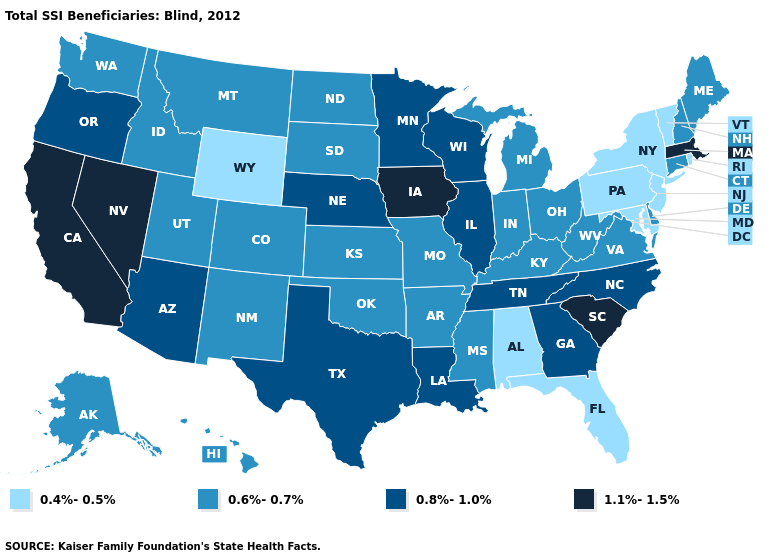Name the states that have a value in the range 0.6%-0.7%?
Write a very short answer. Alaska, Arkansas, Colorado, Connecticut, Delaware, Hawaii, Idaho, Indiana, Kansas, Kentucky, Maine, Michigan, Mississippi, Missouri, Montana, New Hampshire, New Mexico, North Dakota, Ohio, Oklahoma, South Dakota, Utah, Virginia, Washington, West Virginia. Does Utah have the highest value in the USA?
Be succinct. No. Among the states that border Washington , which have the highest value?
Concise answer only. Oregon. Does California have the highest value in the USA?
Short answer required. Yes. Does Nevada have the same value as Connecticut?
Give a very brief answer. No. Which states hav the highest value in the Northeast?
Write a very short answer. Massachusetts. What is the highest value in the USA?
Write a very short answer. 1.1%-1.5%. What is the highest value in the USA?
Write a very short answer. 1.1%-1.5%. Which states have the highest value in the USA?
Quick response, please. California, Iowa, Massachusetts, Nevada, South Carolina. Does South Dakota have the lowest value in the MidWest?
Keep it brief. Yes. Name the states that have a value in the range 1.1%-1.5%?
Write a very short answer. California, Iowa, Massachusetts, Nevada, South Carolina. Does Minnesota have the lowest value in the MidWest?
Concise answer only. No. Among the states that border Connecticut , does Rhode Island have the highest value?
Answer briefly. No. Which states hav the highest value in the MidWest?
Be succinct. Iowa. Is the legend a continuous bar?
Short answer required. No. 